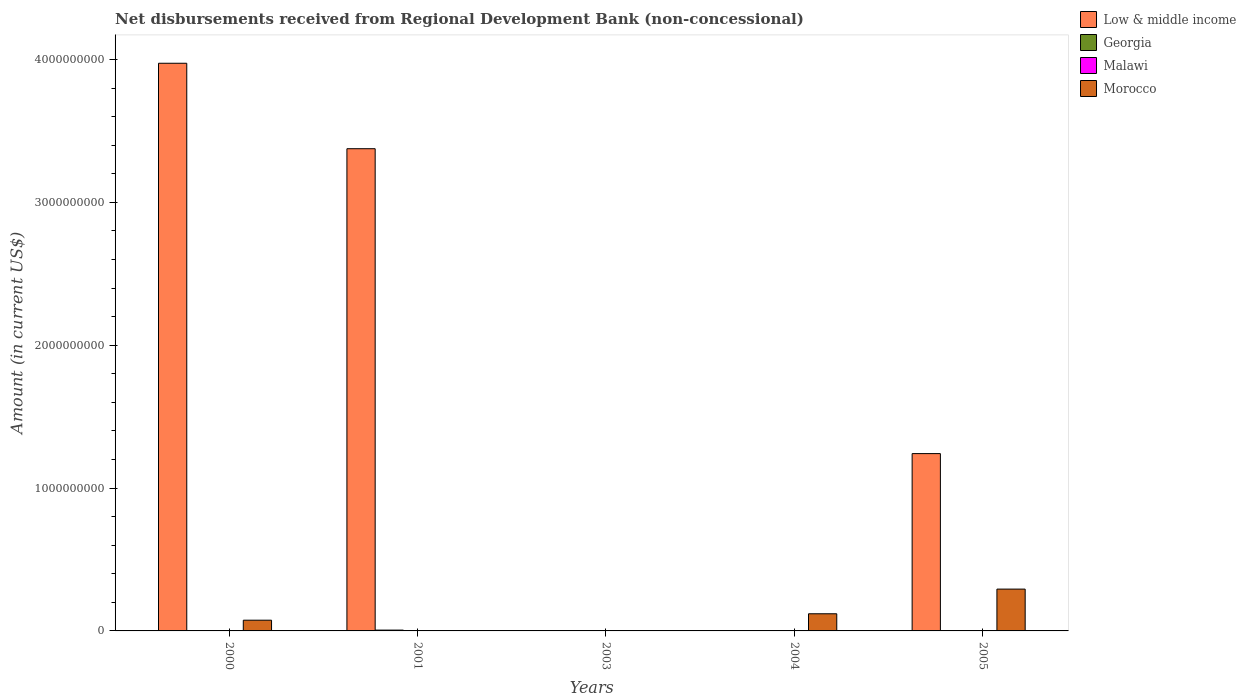How many different coloured bars are there?
Keep it short and to the point. 3. How many bars are there on the 3rd tick from the left?
Your response must be concise. 0. What is the amount of disbursements received from Regional Development Bank in Low & middle income in 2000?
Your answer should be very brief. 3.97e+09. Across all years, what is the maximum amount of disbursements received from Regional Development Bank in Low & middle income?
Provide a succinct answer. 3.97e+09. In which year was the amount of disbursements received from Regional Development Bank in Low & middle income maximum?
Make the answer very short. 2000. What is the difference between the amount of disbursements received from Regional Development Bank in Georgia in 2000 and the amount of disbursements received from Regional Development Bank in Low & middle income in 2003?
Your answer should be very brief. 0. What is the average amount of disbursements received from Regional Development Bank in Low & middle income per year?
Your response must be concise. 1.72e+09. In the year 2000, what is the difference between the amount of disbursements received from Regional Development Bank in Morocco and amount of disbursements received from Regional Development Bank in Low & middle income?
Your answer should be very brief. -3.90e+09. In how many years, is the amount of disbursements received from Regional Development Bank in Malawi greater than 200000000 US$?
Your answer should be compact. 0. Is the amount of disbursements received from Regional Development Bank in Low & middle income in 2000 less than that in 2005?
Provide a short and direct response. No. What is the difference between the highest and the second highest amount of disbursements received from Regional Development Bank in Low & middle income?
Your response must be concise. 5.98e+08. What is the difference between the highest and the lowest amount of disbursements received from Regional Development Bank in Low & middle income?
Your response must be concise. 3.97e+09. Is it the case that in every year, the sum of the amount of disbursements received from Regional Development Bank in Low & middle income and amount of disbursements received from Regional Development Bank in Morocco is greater than the sum of amount of disbursements received from Regional Development Bank in Malawi and amount of disbursements received from Regional Development Bank in Georgia?
Provide a short and direct response. No. How many bars are there?
Keep it short and to the point. 7. Are all the bars in the graph horizontal?
Make the answer very short. No. How many years are there in the graph?
Offer a very short reply. 5. Does the graph contain grids?
Your answer should be very brief. No. Where does the legend appear in the graph?
Give a very brief answer. Top right. How are the legend labels stacked?
Make the answer very short. Vertical. What is the title of the graph?
Provide a short and direct response. Net disbursements received from Regional Development Bank (non-concessional). What is the label or title of the Y-axis?
Ensure brevity in your answer.  Amount (in current US$). What is the Amount (in current US$) of Low & middle income in 2000?
Your answer should be very brief. 3.97e+09. What is the Amount (in current US$) in Georgia in 2000?
Ensure brevity in your answer.  0. What is the Amount (in current US$) in Morocco in 2000?
Ensure brevity in your answer.  7.51e+07. What is the Amount (in current US$) of Low & middle income in 2001?
Provide a succinct answer. 3.38e+09. What is the Amount (in current US$) in Georgia in 2001?
Ensure brevity in your answer.  5.76e+06. What is the Amount (in current US$) of Malawi in 2003?
Keep it short and to the point. 0. What is the Amount (in current US$) of Low & middle income in 2004?
Offer a terse response. 0. What is the Amount (in current US$) of Morocco in 2004?
Give a very brief answer. 1.20e+08. What is the Amount (in current US$) of Low & middle income in 2005?
Keep it short and to the point. 1.24e+09. What is the Amount (in current US$) of Morocco in 2005?
Offer a very short reply. 2.93e+08. Across all years, what is the maximum Amount (in current US$) in Low & middle income?
Provide a short and direct response. 3.97e+09. Across all years, what is the maximum Amount (in current US$) in Georgia?
Provide a short and direct response. 5.76e+06. Across all years, what is the maximum Amount (in current US$) in Morocco?
Ensure brevity in your answer.  2.93e+08. What is the total Amount (in current US$) in Low & middle income in the graph?
Your answer should be compact. 8.59e+09. What is the total Amount (in current US$) of Georgia in the graph?
Ensure brevity in your answer.  5.76e+06. What is the total Amount (in current US$) in Malawi in the graph?
Provide a short and direct response. 0. What is the total Amount (in current US$) of Morocco in the graph?
Your answer should be very brief. 4.88e+08. What is the difference between the Amount (in current US$) in Low & middle income in 2000 and that in 2001?
Your answer should be compact. 5.98e+08. What is the difference between the Amount (in current US$) of Morocco in 2000 and that in 2004?
Provide a succinct answer. -4.49e+07. What is the difference between the Amount (in current US$) in Low & middle income in 2000 and that in 2005?
Give a very brief answer. 2.73e+09. What is the difference between the Amount (in current US$) in Morocco in 2000 and that in 2005?
Make the answer very short. -2.18e+08. What is the difference between the Amount (in current US$) of Low & middle income in 2001 and that in 2005?
Your answer should be compact. 2.13e+09. What is the difference between the Amount (in current US$) of Morocco in 2004 and that in 2005?
Your answer should be compact. -1.73e+08. What is the difference between the Amount (in current US$) in Low & middle income in 2000 and the Amount (in current US$) in Georgia in 2001?
Ensure brevity in your answer.  3.97e+09. What is the difference between the Amount (in current US$) in Low & middle income in 2000 and the Amount (in current US$) in Morocco in 2004?
Provide a succinct answer. 3.85e+09. What is the difference between the Amount (in current US$) in Low & middle income in 2000 and the Amount (in current US$) in Morocco in 2005?
Offer a terse response. 3.68e+09. What is the difference between the Amount (in current US$) in Low & middle income in 2001 and the Amount (in current US$) in Morocco in 2004?
Give a very brief answer. 3.26e+09. What is the difference between the Amount (in current US$) in Georgia in 2001 and the Amount (in current US$) in Morocco in 2004?
Your response must be concise. -1.14e+08. What is the difference between the Amount (in current US$) in Low & middle income in 2001 and the Amount (in current US$) in Morocco in 2005?
Provide a short and direct response. 3.08e+09. What is the difference between the Amount (in current US$) of Georgia in 2001 and the Amount (in current US$) of Morocco in 2005?
Your response must be concise. -2.87e+08. What is the average Amount (in current US$) in Low & middle income per year?
Keep it short and to the point. 1.72e+09. What is the average Amount (in current US$) of Georgia per year?
Provide a succinct answer. 1.15e+06. What is the average Amount (in current US$) of Malawi per year?
Make the answer very short. 0. What is the average Amount (in current US$) in Morocco per year?
Provide a short and direct response. 9.76e+07. In the year 2000, what is the difference between the Amount (in current US$) in Low & middle income and Amount (in current US$) in Morocco?
Provide a succinct answer. 3.90e+09. In the year 2001, what is the difference between the Amount (in current US$) in Low & middle income and Amount (in current US$) in Georgia?
Make the answer very short. 3.37e+09. In the year 2005, what is the difference between the Amount (in current US$) in Low & middle income and Amount (in current US$) in Morocco?
Make the answer very short. 9.49e+08. What is the ratio of the Amount (in current US$) of Low & middle income in 2000 to that in 2001?
Offer a terse response. 1.18. What is the ratio of the Amount (in current US$) in Morocco in 2000 to that in 2004?
Keep it short and to the point. 0.63. What is the ratio of the Amount (in current US$) in Low & middle income in 2000 to that in 2005?
Your response must be concise. 3.2. What is the ratio of the Amount (in current US$) of Morocco in 2000 to that in 2005?
Your response must be concise. 0.26. What is the ratio of the Amount (in current US$) of Low & middle income in 2001 to that in 2005?
Ensure brevity in your answer.  2.72. What is the ratio of the Amount (in current US$) in Morocco in 2004 to that in 2005?
Offer a terse response. 0.41. What is the difference between the highest and the second highest Amount (in current US$) in Low & middle income?
Ensure brevity in your answer.  5.98e+08. What is the difference between the highest and the second highest Amount (in current US$) in Morocco?
Your answer should be very brief. 1.73e+08. What is the difference between the highest and the lowest Amount (in current US$) of Low & middle income?
Keep it short and to the point. 3.97e+09. What is the difference between the highest and the lowest Amount (in current US$) in Georgia?
Your answer should be very brief. 5.76e+06. What is the difference between the highest and the lowest Amount (in current US$) of Morocco?
Provide a short and direct response. 2.93e+08. 